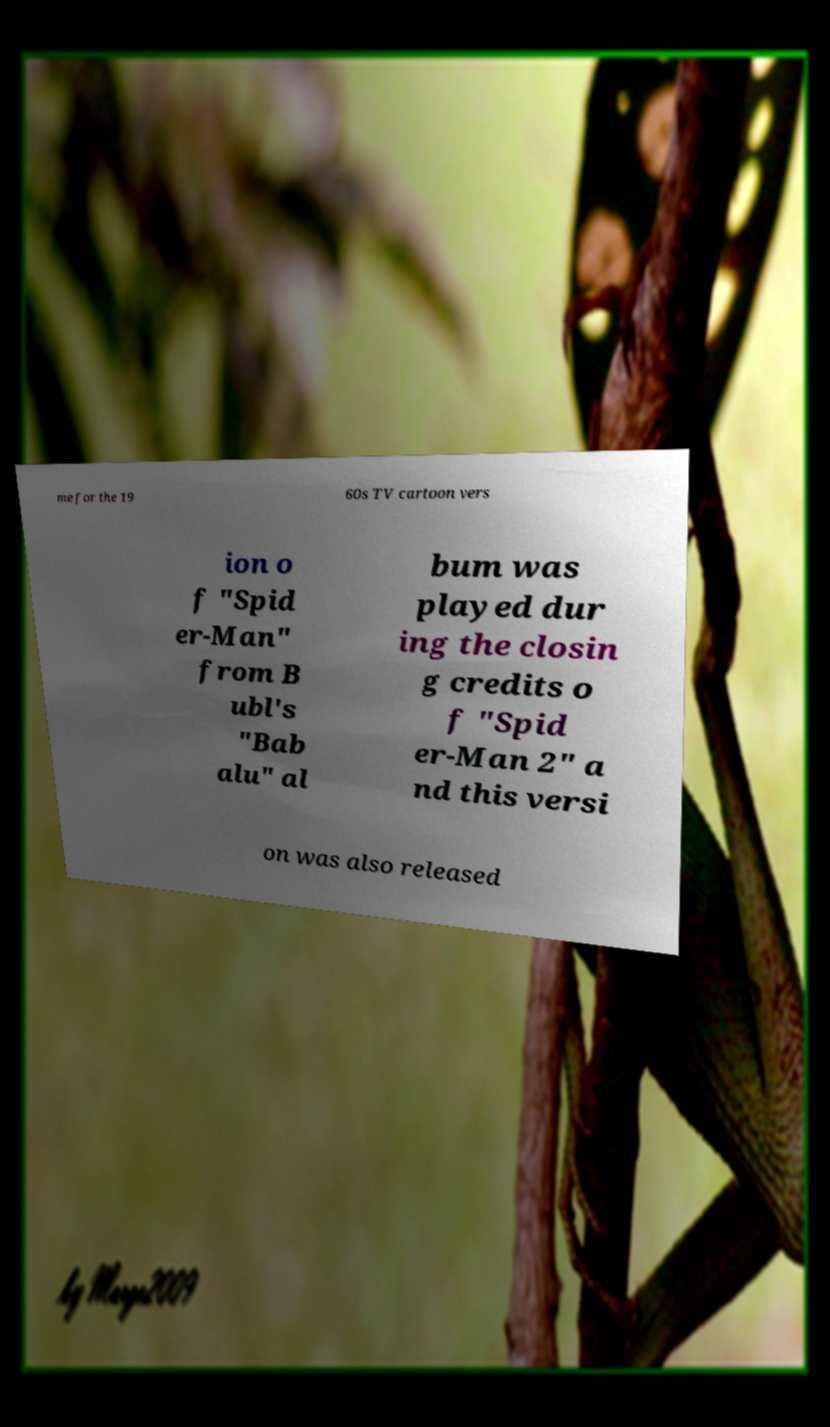I need the written content from this picture converted into text. Can you do that? me for the 19 60s TV cartoon vers ion o f "Spid er-Man" from B ubl's "Bab alu" al bum was played dur ing the closin g credits o f "Spid er-Man 2" a nd this versi on was also released 